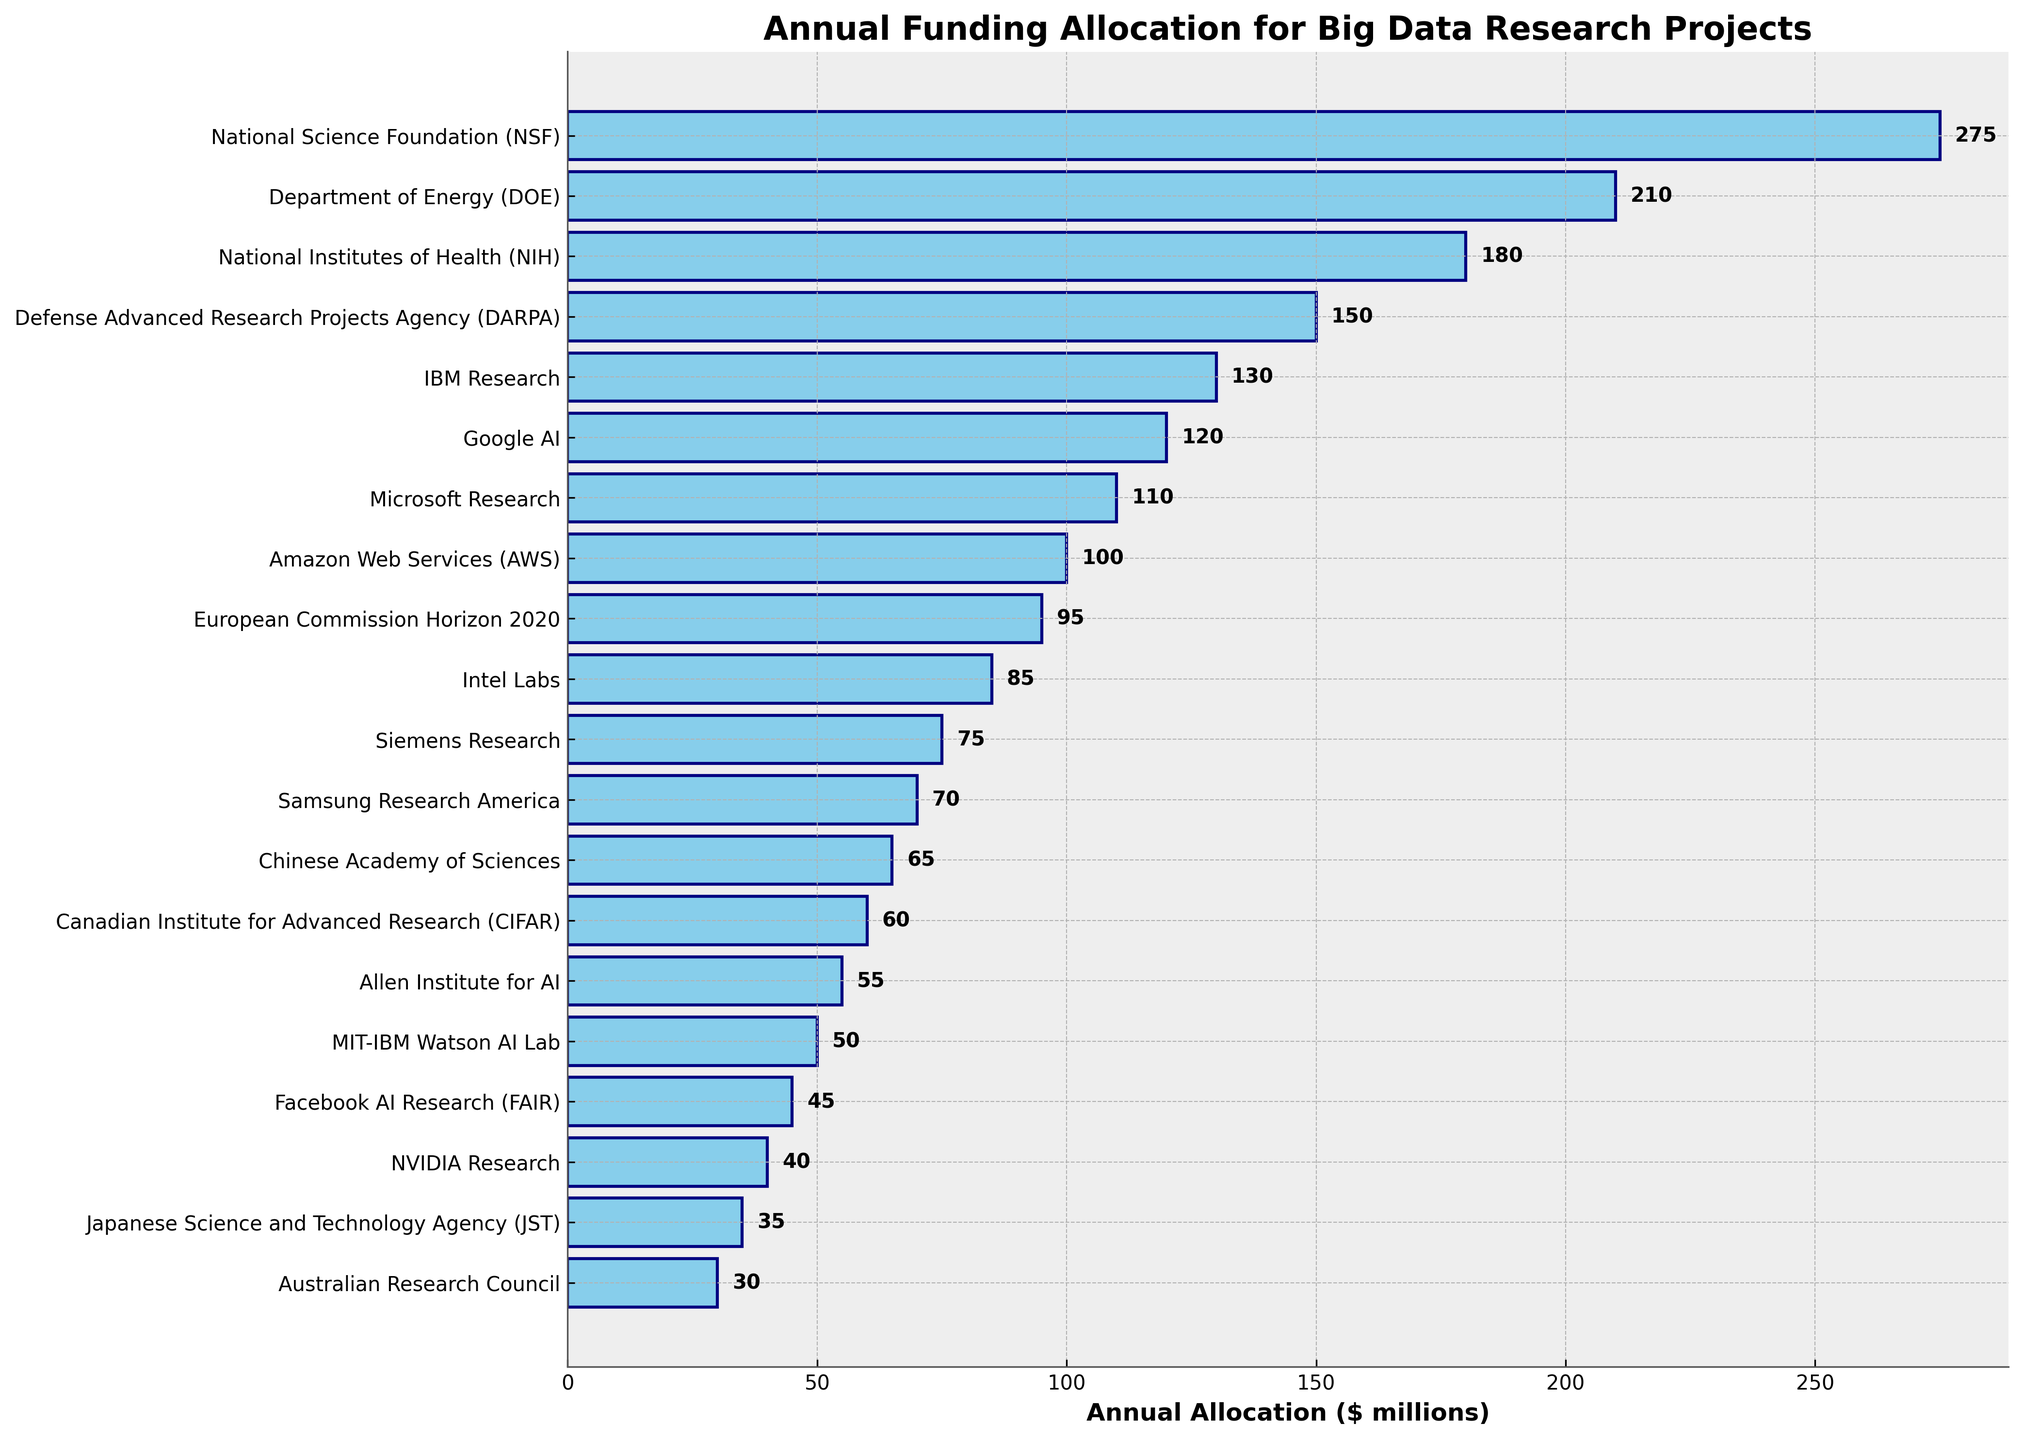Which funding source allocated the highest amount annually for big data research projects? The figure shows different funding sources with varying annual allocations. The National Science Foundation (NSF) is at the top with an allocation of $275 million.
Answer: National Science Foundation (NSF) How much more funding did the National Science Foundation (NSF) allocate compared to the Amazon Web Services (AWS)? According to the figure, the annual allocation for NSF is $275 million, while for AWS, it is $100 million. The difference is 275 - 100 = 175 million.
Answer: $175 million What is the total annual funding allocation from government agencies listed in the figure? Identifying government agencies from the list: NSF ($275 million), DOE ($210 million), NIH ($180 million), DARPA ($150 million), European Commission Horizon 2020 ($95 million), Chinese Academy of Sciences ($65 million), JST ($35 million), and Australian Research Council ($30 million). Adding these amounts: 275 + 210 + 180 + 150 + 95 + 65 + 35 + 30 = 1040 million.
Answer: $1040 million Which private institution has the lowest annual funding allocation for big data research? The figure lists several private institutions; among them, NVIDIA Research has the lowest allocation at $40 million.
Answer: NVIDIA Research Is the funding from Microsoft Research higher or lower than that from IBM Research? The figure indicates Microsoft Research has an allocation of $110 million, while IBM Research has $130 million. Thus, Microsoft Research's funding is lower.
Answer: Lower What is the average annual allocation of the top three private institutions in big data research funding? The top three private institutions by funding are IBM Research ($130 million), Google AI ($120 million), and Microsoft Research ($110 million). The average is calculated as (130 + 120 + 110) / 3 = 360 / 3 = 120 million.
Answer: $120 million How much more does Google AI invest in big data research compared to Facebook AI Research (FAIR)? Google AI's allocation is $120 million, while FAIR's is $45 million. The difference is 120 - 45 = 75 million.
Answer: $75 million Which funding source has an allocation closest to the median of all the listed sources, and what is that median value? To find this, we need to list all funding amounts in ascending order and find the median value. The median is the middle value in the sorted list:
30, 35, 40, 45, 50, 55, 60, 65, 70, 75, 85, 95, 100, 110, 120, 130, 150, 180, 210, 275. The median value (middle of 20 values) is the average of 10th and 11th values, (75 + 85) / 2 = 80. The funding source closest to this value is Intel Labs with $85 million.
Answer: Intel Labs, $80 million 